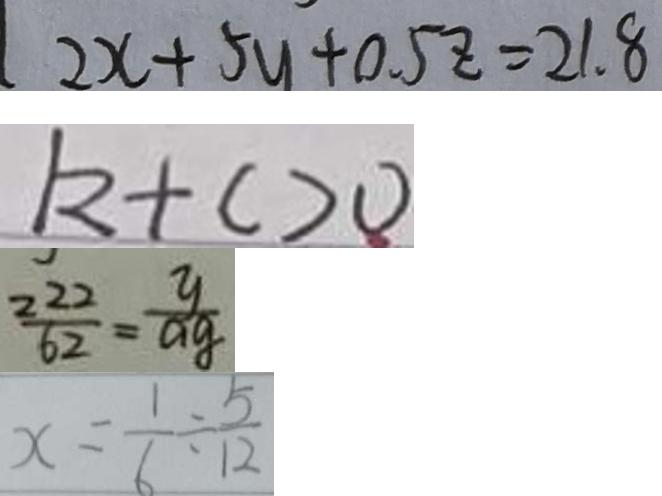<formula> <loc_0><loc_0><loc_500><loc_500>2 x + 5 y + 0 . 5 z = 2 1 . 8 
 k + c > 0 
 \frac { 2 2 2 } { 6 2 } = \frac { y } { a g } 
 x = \frac { 1 } { 6 } \div \frac { 5 } { 1 2 }</formula> 